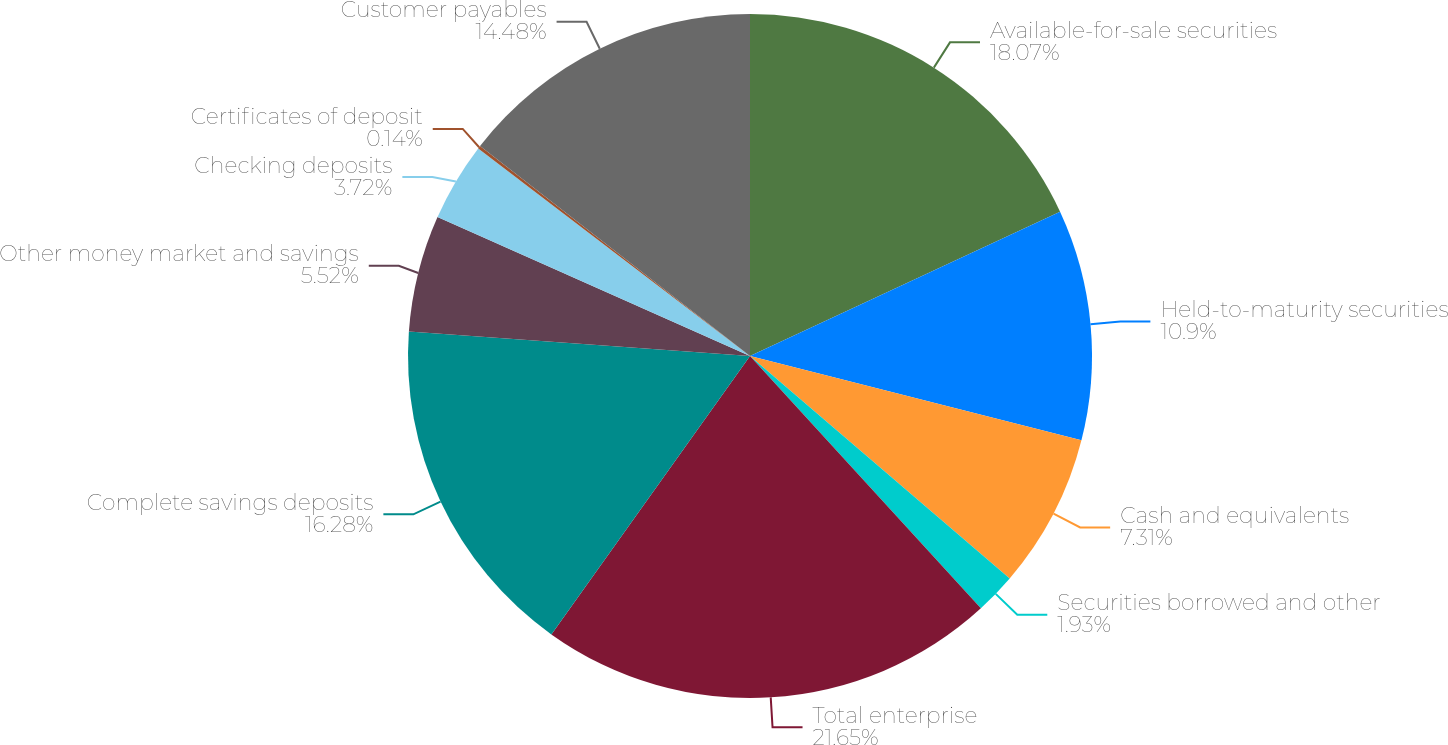Convert chart. <chart><loc_0><loc_0><loc_500><loc_500><pie_chart><fcel>Available-for-sale securities<fcel>Held-to-maturity securities<fcel>Cash and equivalents<fcel>Securities borrowed and other<fcel>Total enterprise<fcel>Complete savings deposits<fcel>Other money market and savings<fcel>Checking deposits<fcel>Certificates of deposit<fcel>Customer payables<nl><fcel>18.07%<fcel>10.9%<fcel>7.31%<fcel>1.93%<fcel>21.66%<fcel>16.28%<fcel>5.52%<fcel>3.72%<fcel>0.14%<fcel>14.48%<nl></chart> 